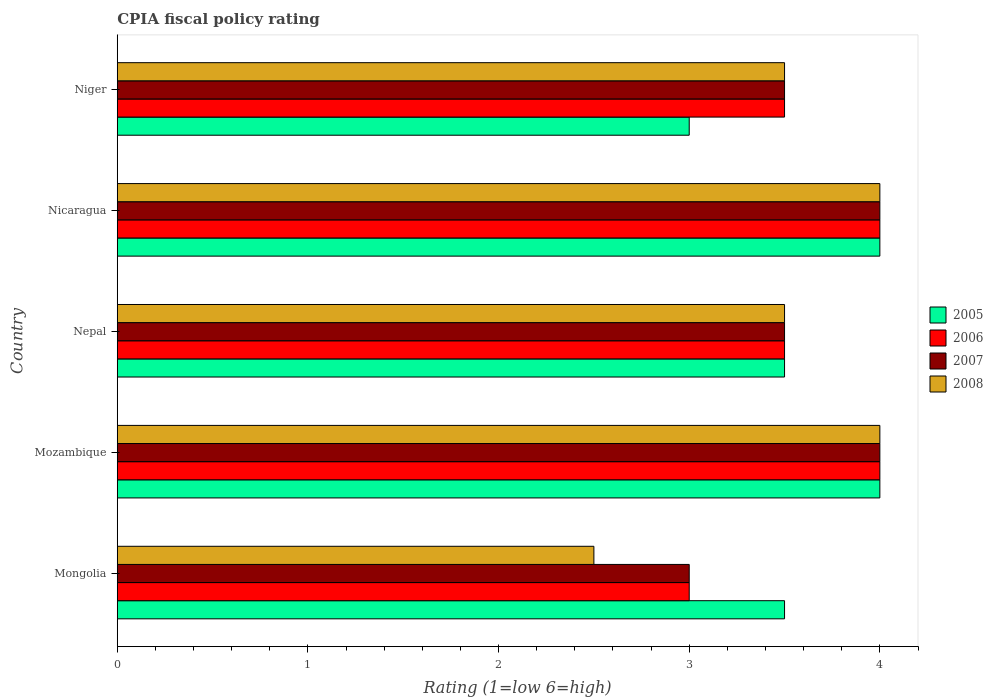How many bars are there on the 3rd tick from the top?
Your response must be concise. 4. How many bars are there on the 4th tick from the bottom?
Make the answer very short. 4. What is the label of the 5th group of bars from the top?
Give a very brief answer. Mongolia. In how many cases, is the number of bars for a given country not equal to the number of legend labels?
Offer a very short reply. 0. What is the CPIA rating in 2007 in Mongolia?
Offer a very short reply. 3. In which country was the CPIA rating in 2006 maximum?
Offer a very short reply. Mozambique. In which country was the CPIA rating in 2007 minimum?
Ensure brevity in your answer.  Mongolia. What is the total CPIA rating in 2005 in the graph?
Your answer should be very brief. 18. What is the difference between the CPIA rating in 2007 in Mongolia and the CPIA rating in 2005 in Nepal?
Offer a terse response. -0.5. In how many countries, is the CPIA rating in 2006 greater than 3.2 ?
Give a very brief answer. 4. Is the CPIA rating in 2008 in Mongolia less than that in Niger?
Your response must be concise. Yes. Is the difference between the CPIA rating in 2007 in Mozambique and Nicaragua greater than the difference between the CPIA rating in 2008 in Mozambique and Nicaragua?
Offer a terse response. No. What is the difference between the highest and the second highest CPIA rating in 2006?
Your answer should be compact. 0. In how many countries, is the CPIA rating in 2006 greater than the average CPIA rating in 2006 taken over all countries?
Give a very brief answer. 2. Is the sum of the CPIA rating in 2006 in Mongolia and Mozambique greater than the maximum CPIA rating in 2008 across all countries?
Give a very brief answer. Yes. What does the 1st bar from the top in Nepal represents?
Offer a very short reply. 2008. What does the 4th bar from the bottom in Nepal represents?
Your answer should be very brief. 2008. Is it the case that in every country, the sum of the CPIA rating in 2007 and CPIA rating in 2006 is greater than the CPIA rating in 2008?
Offer a terse response. Yes. What is the difference between two consecutive major ticks on the X-axis?
Give a very brief answer. 1. Does the graph contain grids?
Keep it short and to the point. No. How many legend labels are there?
Offer a very short reply. 4. What is the title of the graph?
Make the answer very short. CPIA fiscal policy rating. What is the Rating (1=low 6=high) of 2006 in Mozambique?
Your answer should be compact. 4. What is the Rating (1=low 6=high) of 2008 in Mozambique?
Provide a succinct answer. 4. What is the Rating (1=low 6=high) of 2005 in Nepal?
Your answer should be very brief. 3.5. What is the Rating (1=low 6=high) in 2006 in Nepal?
Your response must be concise. 3.5. What is the Rating (1=low 6=high) in 2005 in Nicaragua?
Offer a very short reply. 4. What is the Rating (1=low 6=high) of 2005 in Niger?
Provide a short and direct response. 3. What is the Rating (1=low 6=high) in 2008 in Niger?
Ensure brevity in your answer.  3.5. Across all countries, what is the maximum Rating (1=low 6=high) in 2006?
Your answer should be very brief. 4. Across all countries, what is the minimum Rating (1=low 6=high) in 2006?
Your response must be concise. 3. Across all countries, what is the minimum Rating (1=low 6=high) of 2007?
Provide a short and direct response. 3. Across all countries, what is the minimum Rating (1=low 6=high) in 2008?
Your answer should be compact. 2.5. What is the total Rating (1=low 6=high) of 2005 in the graph?
Make the answer very short. 18. What is the total Rating (1=low 6=high) in 2007 in the graph?
Offer a very short reply. 18. What is the difference between the Rating (1=low 6=high) in 2007 in Mongolia and that in Mozambique?
Offer a terse response. -1. What is the difference between the Rating (1=low 6=high) of 2005 in Mongolia and that in Nepal?
Ensure brevity in your answer.  0. What is the difference between the Rating (1=low 6=high) of 2006 in Mongolia and that in Nepal?
Your answer should be very brief. -0.5. What is the difference between the Rating (1=low 6=high) of 2007 in Mongolia and that in Nepal?
Your response must be concise. -0.5. What is the difference between the Rating (1=low 6=high) of 2008 in Mongolia and that in Nepal?
Your answer should be very brief. -1. What is the difference between the Rating (1=low 6=high) of 2007 in Mongolia and that in Nicaragua?
Ensure brevity in your answer.  -1. What is the difference between the Rating (1=low 6=high) in 2008 in Mongolia and that in Nicaragua?
Your response must be concise. -1.5. What is the difference between the Rating (1=low 6=high) of 2006 in Mongolia and that in Niger?
Your response must be concise. -0.5. What is the difference between the Rating (1=low 6=high) in 2008 in Mongolia and that in Niger?
Your answer should be very brief. -1. What is the difference between the Rating (1=low 6=high) in 2007 in Mozambique and that in Nepal?
Your answer should be compact. 0.5. What is the difference between the Rating (1=low 6=high) of 2006 in Mozambique and that in Nicaragua?
Keep it short and to the point. 0. What is the difference between the Rating (1=low 6=high) in 2007 in Mozambique and that in Nicaragua?
Your response must be concise. 0. What is the difference between the Rating (1=low 6=high) in 2007 in Mozambique and that in Niger?
Offer a very short reply. 0.5. What is the difference between the Rating (1=low 6=high) in 2005 in Nepal and that in Nicaragua?
Provide a short and direct response. -0.5. What is the difference between the Rating (1=low 6=high) of 2006 in Nepal and that in Nicaragua?
Offer a terse response. -0.5. What is the difference between the Rating (1=low 6=high) of 2007 in Nepal and that in Nicaragua?
Ensure brevity in your answer.  -0.5. What is the difference between the Rating (1=low 6=high) of 2008 in Nepal and that in Nicaragua?
Keep it short and to the point. -0.5. What is the difference between the Rating (1=low 6=high) of 2005 in Nepal and that in Niger?
Your answer should be very brief. 0.5. What is the difference between the Rating (1=low 6=high) of 2007 in Nepal and that in Niger?
Offer a terse response. 0. What is the difference between the Rating (1=low 6=high) in 2008 in Nepal and that in Niger?
Your answer should be compact. 0. What is the difference between the Rating (1=low 6=high) in 2007 in Nicaragua and that in Niger?
Your answer should be very brief. 0.5. What is the difference between the Rating (1=low 6=high) in 2006 in Mongolia and the Rating (1=low 6=high) in 2007 in Mozambique?
Ensure brevity in your answer.  -1. What is the difference between the Rating (1=low 6=high) in 2006 in Mongolia and the Rating (1=low 6=high) in 2008 in Mozambique?
Provide a succinct answer. -1. What is the difference between the Rating (1=low 6=high) in 2007 in Mongolia and the Rating (1=low 6=high) in 2008 in Mozambique?
Offer a terse response. -1. What is the difference between the Rating (1=low 6=high) of 2005 in Mongolia and the Rating (1=low 6=high) of 2008 in Nepal?
Your answer should be very brief. 0. What is the difference between the Rating (1=low 6=high) in 2006 in Mongolia and the Rating (1=low 6=high) in 2008 in Nepal?
Make the answer very short. -0.5. What is the difference between the Rating (1=low 6=high) of 2005 in Mongolia and the Rating (1=low 6=high) of 2007 in Nicaragua?
Make the answer very short. -0.5. What is the difference between the Rating (1=low 6=high) of 2005 in Mongolia and the Rating (1=low 6=high) of 2008 in Nicaragua?
Offer a terse response. -0.5. What is the difference between the Rating (1=low 6=high) in 2007 in Mongolia and the Rating (1=low 6=high) in 2008 in Nicaragua?
Your answer should be compact. -1. What is the difference between the Rating (1=low 6=high) in 2005 in Mongolia and the Rating (1=low 6=high) in 2006 in Niger?
Keep it short and to the point. 0. What is the difference between the Rating (1=low 6=high) in 2005 in Mongolia and the Rating (1=low 6=high) in 2007 in Niger?
Offer a terse response. 0. What is the difference between the Rating (1=low 6=high) in 2005 in Mongolia and the Rating (1=low 6=high) in 2008 in Niger?
Your answer should be compact. 0. What is the difference between the Rating (1=low 6=high) in 2006 in Mongolia and the Rating (1=low 6=high) in 2008 in Niger?
Make the answer very short. -0.5. What is the difference between the Rating (1=low 6=high) in 2005 in Mozambique and the Rating (1=low 6=high) in 2006 in Nepal?
Your answer should be compact. 0.5. What is the difference between the Rating (1=low 6=high) in 2005 in Mozambique and the Rating (1=low 6=high) in 2007 in Nepal?
Offer a terse response. 0.5. What is the difference between the Rating (1=low 6=high) of 2005 in Mozambique and the Rating (1=low 6=high) of 2008 in Nepal?
Provide a short and direct response. 0.5. What is the difference between the Rating (1=low 6=high) in 2005 in Mozambique and the Rating (1=low 6=high) in 2006 in Nicaragua?
Provide a short and direct response. 0. What is the difference between the Rating (1=low 6=high) in 2005 in Mozambique and the Rating (1=low 6=high) in 2007 in Nicaragua?
Your response must be concise. 0. What is the difference between the Rating (1=low 6=high) of 2005 in Mozambique and the Rating (1=low 6=high) of 2008 in Nicaragua?
Make the answer very short. 0. What is the difference between the Rating (1=low 6=high) in 2007 in Mozambique and the Rating (1=low 6=high) in 2008 in Nicaragua?
Offer a very short reply. 0. What is the difference between the Rating (1=low 6=high) of 2005 in Mozambique and the Rating (1=low 6=high) of 2007 in Niger?
Offer a very short reply. 0.5. What is the difference between the Rating (1=low 6=high) of 2007 in Mozambique and the Rating (1=low 6=high) of 2008 in Niger?
Offer a very short reply. 0.5. What is the difference between the Rating (1=low 6=high) of 2006 in Nepal and the Rating (1=low 6=high) of 2007 in Nicaragua?
Offer a terse response. -0.5. What is the difference between the Rating (1=low 6=high) in 2006 in Nepal and the Rating (1=low 6=high) in 2007 in Niger?
Provide a succinct answer. 0. What is the difference between the Rating (1=low 6=high) in 2005 in Nicaragua and the Rating (1=low 6=high) in 2008 in Niger?
Keep it short and to the point. 0.5. What is the difference between the Rating (1=low 6=high) in 2006 in Nicaragua and the Rating (1=low 6=high) in 2007 in Niger?
Your answer should be compact. 0.5. What is the difference between the Rating (1=low 6=high) in 2007 in Nicaragua and the Rating (1=low 6=high) in 2008 in Niger?
Your answer should be very brief. 0.5. What is the average Rating (1=low 6=high) of 2005 per country?
Provide a short and direct response. 3.6. What is the difference between the Rating (1=low 6=high) in 2005 and Rating (1=low 6=high) in 2006 in Mongolia?
Provide a short and direct response. 0.5. What is the difference between the Rating (1=low 6=high) in 2005 and Rating (1=low 6=high) in 2008 in Mongolia?
Make the answer very short. 1. What is the difference between the Rating (1=low 6=high) in 2006 and Rating (1=low 6=high) in 2007 in Mongolia?
Ensure brevity in your answer.  0. What is the difference between the Rating (1=low 6=high) in 2006 and Rating (1=low 6=high) in 2008 in Mongolia?
Your answer should be very brief. 0.5. What is the difference between the Rating (1=low 6=high) of 2005 and Rating (1=low 6=high) of 2006 in Mozambique?
Offer a terse response. 0. What is the difference between the Rating (1=low 6=high) in 2005 and Rating (1=low 6=high) in 2008 in Mozambique?
Make the answer very short. 0. What is the difference between the Rating (1=low 6=high) in 2005 and Rating (1=low 6=high) in 2007 in Nepal?
Offer a terse response. 0. What is the difference between the Rating (1=low 6=high) of 2005 and Rating (1=low 6=high) of 2008 in Nepal?
Offer a terse response. 0. What is the difference between the Rating (1=low 6=high) in 2006 and Rating (1=low 6=high) in 2008 in Nepal?
Offer a very short reply. 0. What is the difference between the Rating (1=low 6=high) in 2005 and Rating (1=low 6=high) in 2006 in Nicaragua?
Provide a succinct answer. 0. What is the difference between the Rating (1=low 6=high) in 2005 and Rating (1=low 6=high) in 2007 in Nicaragua?
Offer a terse response. 0. What is the difference between the Rating (1=low 6=high) of 2006 and Rating (1=low 6=high) of 2008 in Nicaragua?
Make the answer very short. 0. What is the difference between the Rating (1=low 6=high) of 2007 and Rating (1=low 6=high) of 2008 in Nicaragua?
Ensure brevity in your answer.  0. What is the difference between the Rating (1=low 6=high) in 2005 and Rating (1=low 6=high) in 2006 in Niger?
Provide a succinct answer. -0.5. What is the difference between the Rating (1=low 6=high) in 2005 and Rating (1=low 6=high) in 2008 in Niger?
Your answer should be very brief. -0.5. What is the difference between the Rating (1=low 6=high) in 2006 and Rating (1=low 6=high) in 2007 in Niger?
Provide a short and direct response. 0. What is the difference between the Rating (1=low 6=high) of 2006 and Rating (1=low 6=high) of 2008 in Niger?
Your answer should be very brief. 0. What is the difference between the Rating (1=low 6=high) of 2007 and Rating (1=low 6=high) of 2008 in Niger?
Your answer should be compact. 0. What is the ratio of the Rating (1=low 6=high) of 2005 in Mongolia to that in Mozambique?
Keep it short and to the point. 0.88. What is the ratio of the Rating (1=low 6=high) in 2007 in Mongolia to that in Mozambique?
Make the answer very short. 0.75. What is the ratio of the Rating (1=low 6=high) of 2008 in Mongolia to that in Mozambique?
Keep it short and to the point. 0.62. What is the ratio of the Rating (1=low 6=high) in 2005 in Mongolia to that in Nepal?
Provide a succinct answer. 1. What is the ratio of the Rating (1=low 6=high) in 2007 in Mongolia to that in Nicaragua?
Give a very brief answer. 0.75. What is the ratio of the Rating (1=low 6=high) in 2006 in Mongolia to that in Niger?
Your response must be concise. 0.86. What is the ratio of the Rating (1=low 6=high) of 2007 in Mongolia to that in Niger?
Your response must be concise. 0.86. What is the ratio of the Rating (1=low 6=high) in 2006 in Mozambique to that in Nepal?
Ensure brevity in your answer.  1.14. What is the ratio of the Rating (1=low 6=high) in 2007 in Mozambique to that in Nepal?
Provide a succinct answer. 1.14. What is the ratio of the Rating (1=low 6=high) in 2005 in Mozambique to that in Nicaragua?
Ensure brevity in your answer.  1. What is the ratio of the Rating (1=low 6=high) in 2006 in Mozambique to that in Nicaragua?
Provide a short and direct response. 1. What is the ratio of the Rating (1=low 6=high) of 2005 in Nepal to that in Nicaragua?
Make the answer very short. 0.88. What is the ratio of the Rating (1=low 6=high) in 2006 in Nepal to that in Nicaragua?
Provide a succinct answer. 0.88. What is the ratio of the Rating (1=low 6=high) in 2005 in Nepal to that in Niger?
Offer a very short reply. 1.17. What is the ratio of the Rating (1=low 6=high) of 2006 in Nepal to that in Niger?
Provide a succinct answer. 1. What is the ratio of the Rating (1=low 6=high) of 2007 in Nepal to that in Niger?
Ensure brevity in your answer.  1. What is the ratio of the Rating (1=low 6=high) of 2008 in Nepal to that in Niger?
Your answer should be compact. 1. What is the ratio of the Rating (1=low 6=high) in 2005 in Nicaragua to that in Niger?
Give a very brief answer. 1.33. What is the ratio of the Rating (1=low 6=high) in 2006 in Nicaragua to that in Niger?
Provide a short and direct response. 1.14. What is the ratio of the Rating (1=low 6=high) in 2007 in Nicaragua to that in Niger?
Your answer should be compact. 1.14. What is the difference between the highest and the second highest Rating (1=low 6=high) in 2005?
Make the answer very short. 0. What is the difference between the highest and the lowest Rating (1=low 6=high) of 2006?
Your answer should be compact. 1. 